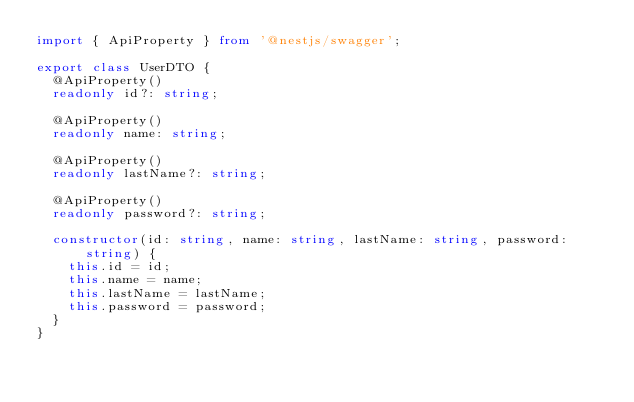Convert code to text. <code><loc_0><loc_0><loc_500><loc_500><_TypeScript_>import { ApiProperty } from '@nestjs/swagger';

export class UserDTO {
  @ApiProperty()
  readonly id?: string;

  @ApiProperty()
  readonly name: string;

  @ApiProperty()
  readonly lastName?: string;

  @ApiProperty()
  readonly password?: string;

  constructor(id: string, name: string, lastName: string, password: string) {
    this.id = id;
    this.name = name;
    this.lastName = lastName;
    this.password = password;
  }
}
</code> 